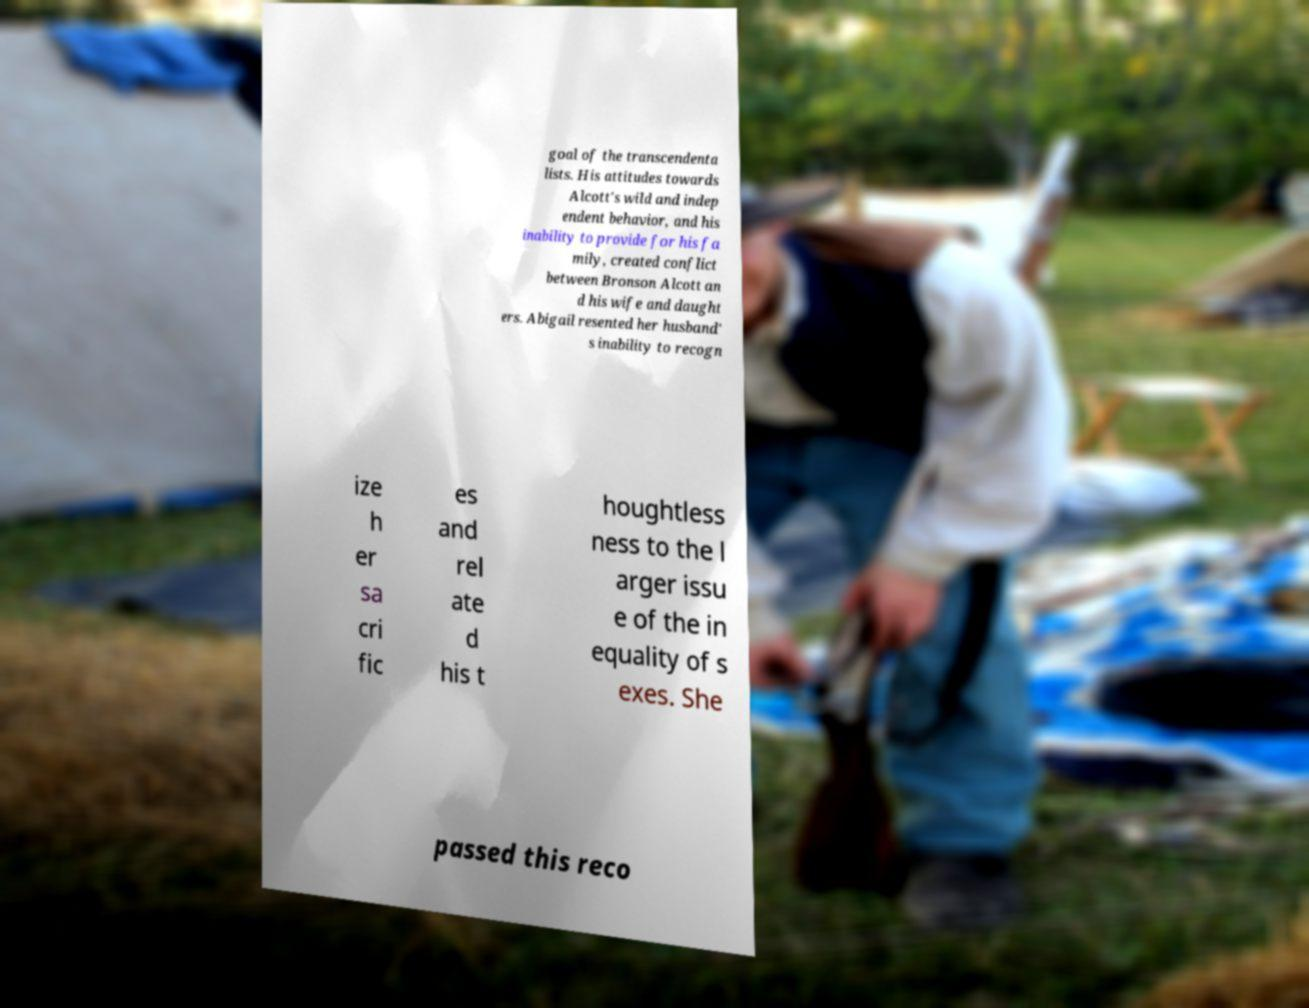For documentation purposes, I need the text within this image transcribed. Could you provide that? goal of the transcendenta lists. His attitudes towards Alcott's wild and indep endent behavior, and his inability to provide for his fa mily, created conflict between Bronson Alcott an d his wife and daught ers. Abigail resented her husband' s inability to recogn ize h er sa cri fic es and rel ate d his t houghtless ness to the l arger issu e of the in equality of s exes. She passed this reco 